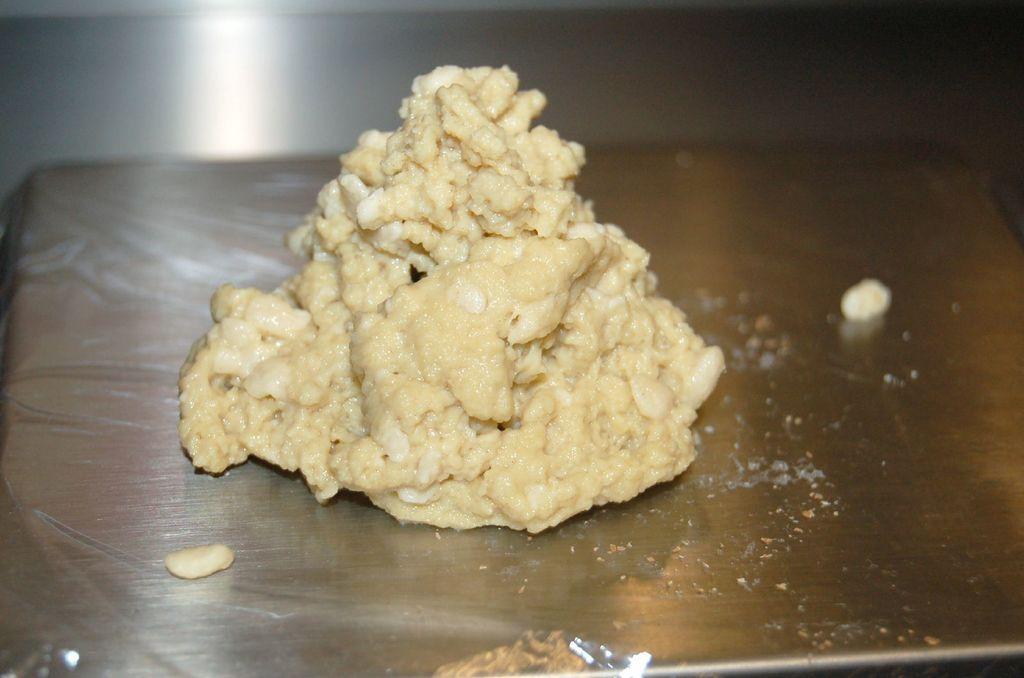Can you describe this image briefly? In the picture there is some food item kept on a sheet that is kept on steel table. 